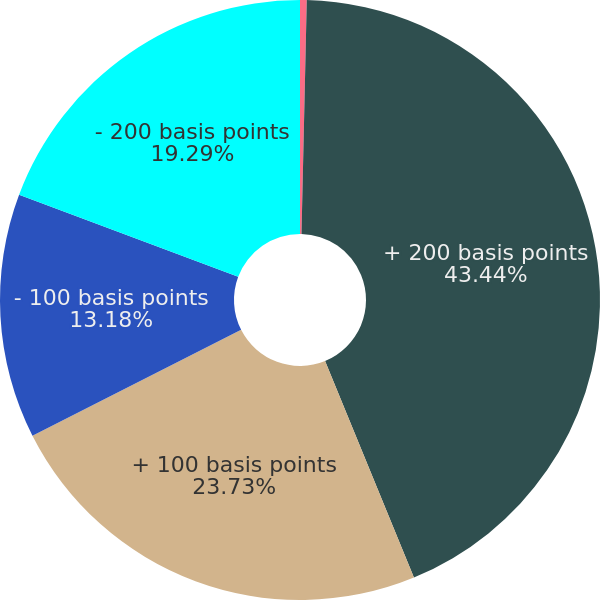Convert chart. <chart><loc_0><loc_0><loc_500><loc_500><pie_chart><fcel>Changes in Interest Rates<fcel>+ 200 basis points<fcel>+ 100 basis points<fcel>- 100 basis points<fcel>- 200 basis points<nl><fcel>0.36%<fcel>43.44%<fcel>23.73%<fcel>13.18%<fcel>19.29%<nl></chart> 